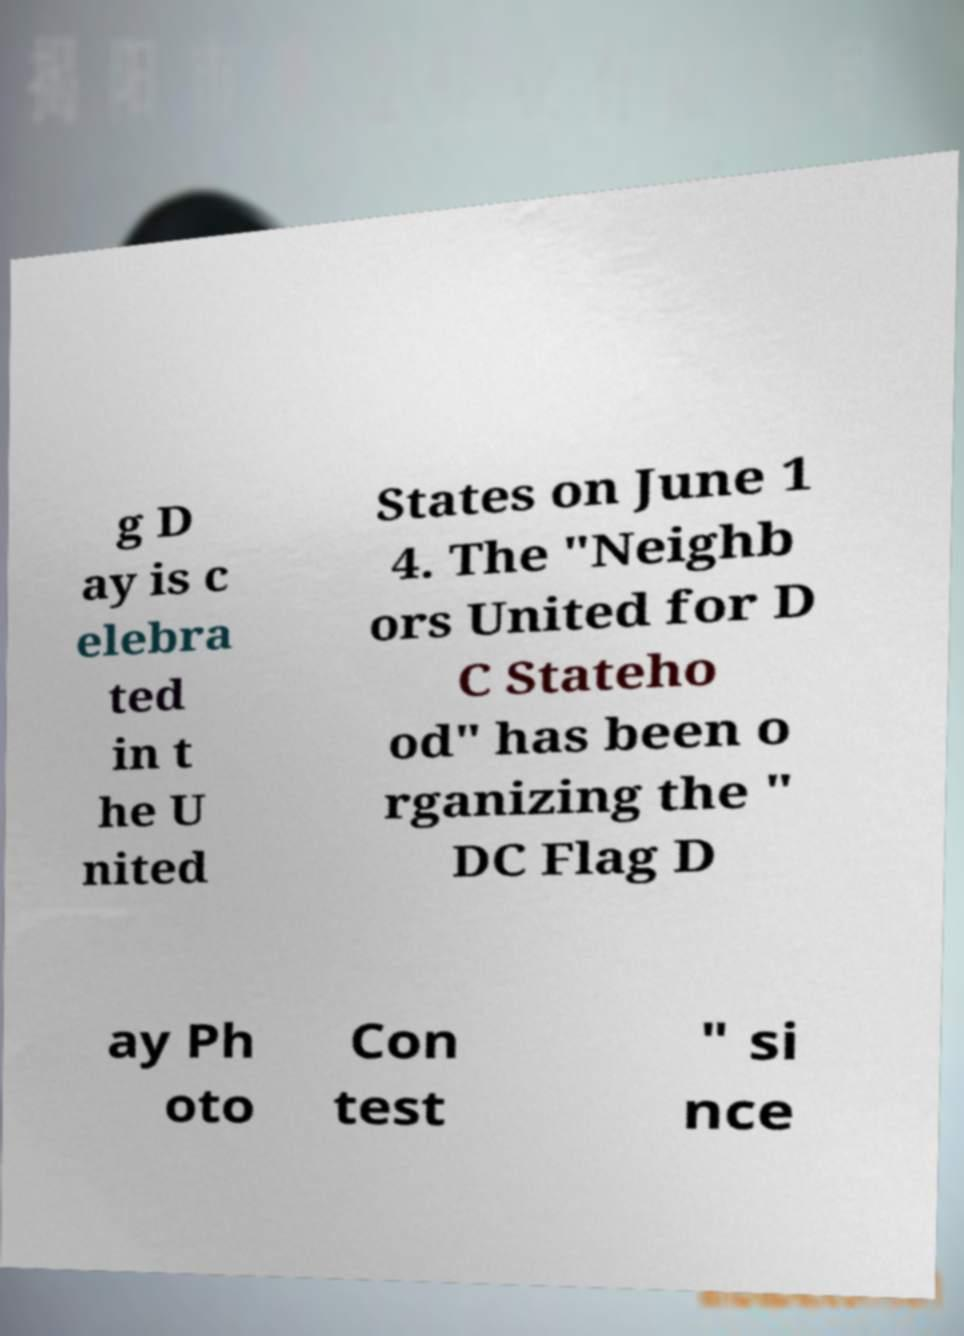What messages or text are displayed in this image? I need them in a readable, typed format. g D ay is c elebra ted in t he U nited States on June 1 4. The "Neighb ors United for D C Stateho od" has been o rganizing the " DC Flag D ay Ph oto Con test " si nce 